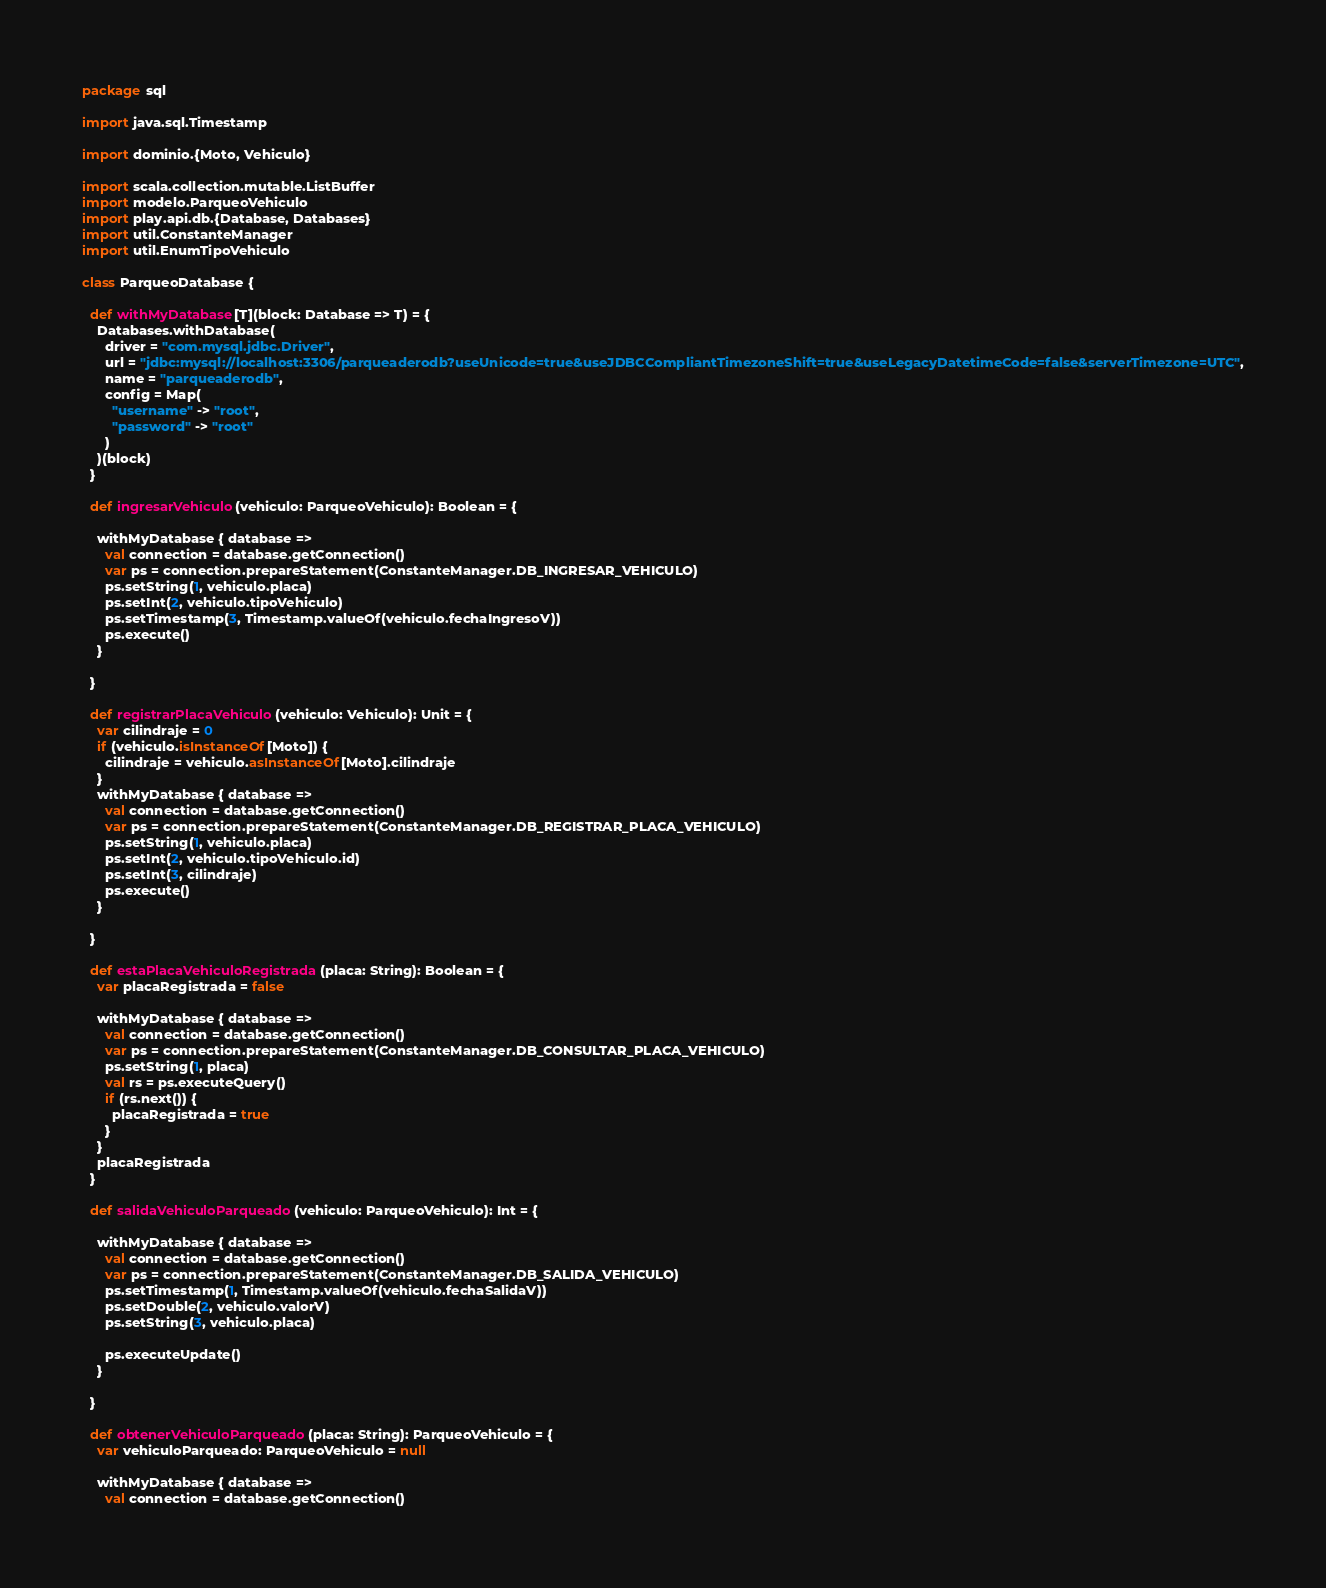Convert code to text. <code><loc_0><loc_0><loc_500><loc_500><_Scala_>package sql

import java.sql.Timestamp

import dominio.{Moto, Vehiculo}

import scala.collection.mutable.ListBuffer
import modelo.ParqueoVehiculo
import play.api.db.{Database, Databases}
import util.ConstanteManager
import util.EnumTipoVehiculo

class ParqueoDatabase {

  def withMyDatabase[T](block: Database => T) = {
    Databases.withDatabase(
      driver = "com.mysql.jdbc.Driver",
      url = "jdbc:mysql://localhost:3306/parqueaderodb?useUnicode=true&useJDBCCompliantTimezoneShift=true&useLegacyDatetimeCode=false&serverTimezone=UTC",
      name = "parqueaderodb",
      config = Map(
        "username" -> "root",
        "password" -> "root"
      )
    )(block)
  }

  def ingresarVehiculo(vehiculo: ParqueoVehiculo): Boolean = {

    withMyDatabase { database =>
      val connection = database.getConnection()
      var ps = connection.prepareStatement(ConstanteManager.DB_INGRESAR_VEHICULO)
      ps.setString(1, vehiculo.placa)
      ps.setInt(2, vehiculo.tipoVehiculo)
      ps.setTimestamp(3, Timestamp.valueOf(vehiculo.fechaIngresoV))
      ps.execute()
    }

  }

  def registrarPlacaVehiculo(vehiculo: Vehiculo): Unit = {
    var cilindraje = 0
    if (vehiculo.isInstanceOf[Moto]) {
      cilindraje = vehiculo.asInstanceOf[Moto].cilindraje
    }
    withMyDatabase { database =>
      val connection = database.getConnection()
      var ps = connection.prepareStatement(ConstanteManager.DB_REGISTRAR_PLACA_VEHICULO)
      ps.setString(1, vehiculo.placa)
      ps.setInt(2, vehiculo.tipoVehiculo.id)
      ps.setInt(3, cilindraje)
      ps.execute()
    }

  }

  def estaPlacaVehiculoRegistrada(placa: String): Boolean = {
    var placaRegistrada = false

    withMyDatabase { database =>
      val connection = database.getConnection()
      var ps = connection.prepareStatement(ConstanteManager.DB_CONSULTAR_PLACA_VEHICULO)
      ps.setString(1, placa)
      val rs = ps.executeQuery()
      if (rs.next()) {
        placaRegistrada = true
      }
    }
    placaRegistrada
  }

  def salidaVehiculoParqueado(vehiculo: ParqueoVehiculo): Int = {

    withMyDatabase { database =>
      val connection = database.getConnection()
      var ps = connection.prepareStatement(ConstanteManager.DB_SALIDA_VEHICULO)
      ps.setTimestamp(1, Timestamp.valueOf(vehiculo.fechaSalidaV))
      ps.setDouble(2, vehiculo.valorV)
      ps.setString(3, vehiculo.placa)

      ps.executeUpdate()
    }

  }

  def obtenerVehiculoParqueado(placa: String): ParqueoVehiculo = {
    var vehiculoParqueado: ParqueoVehiculo = null

    withMyDatabase { database =>
      val connection = database.getConnection()</code> 